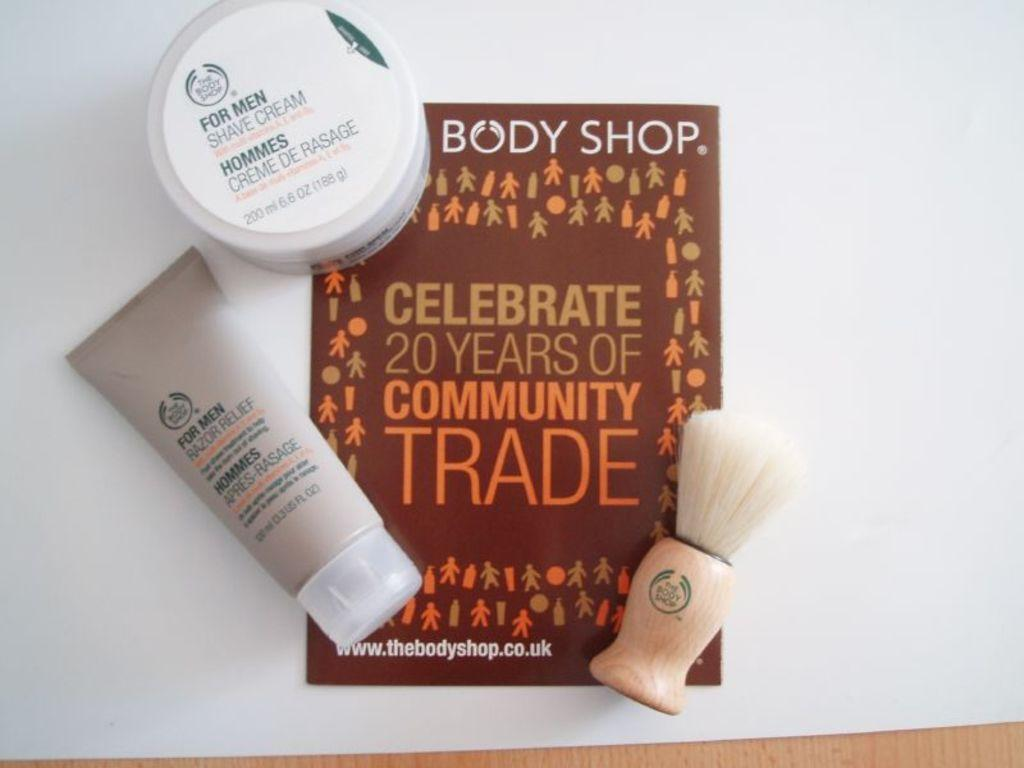<image>
Describe the image concisely. Several items from The Body Shop are shown. 